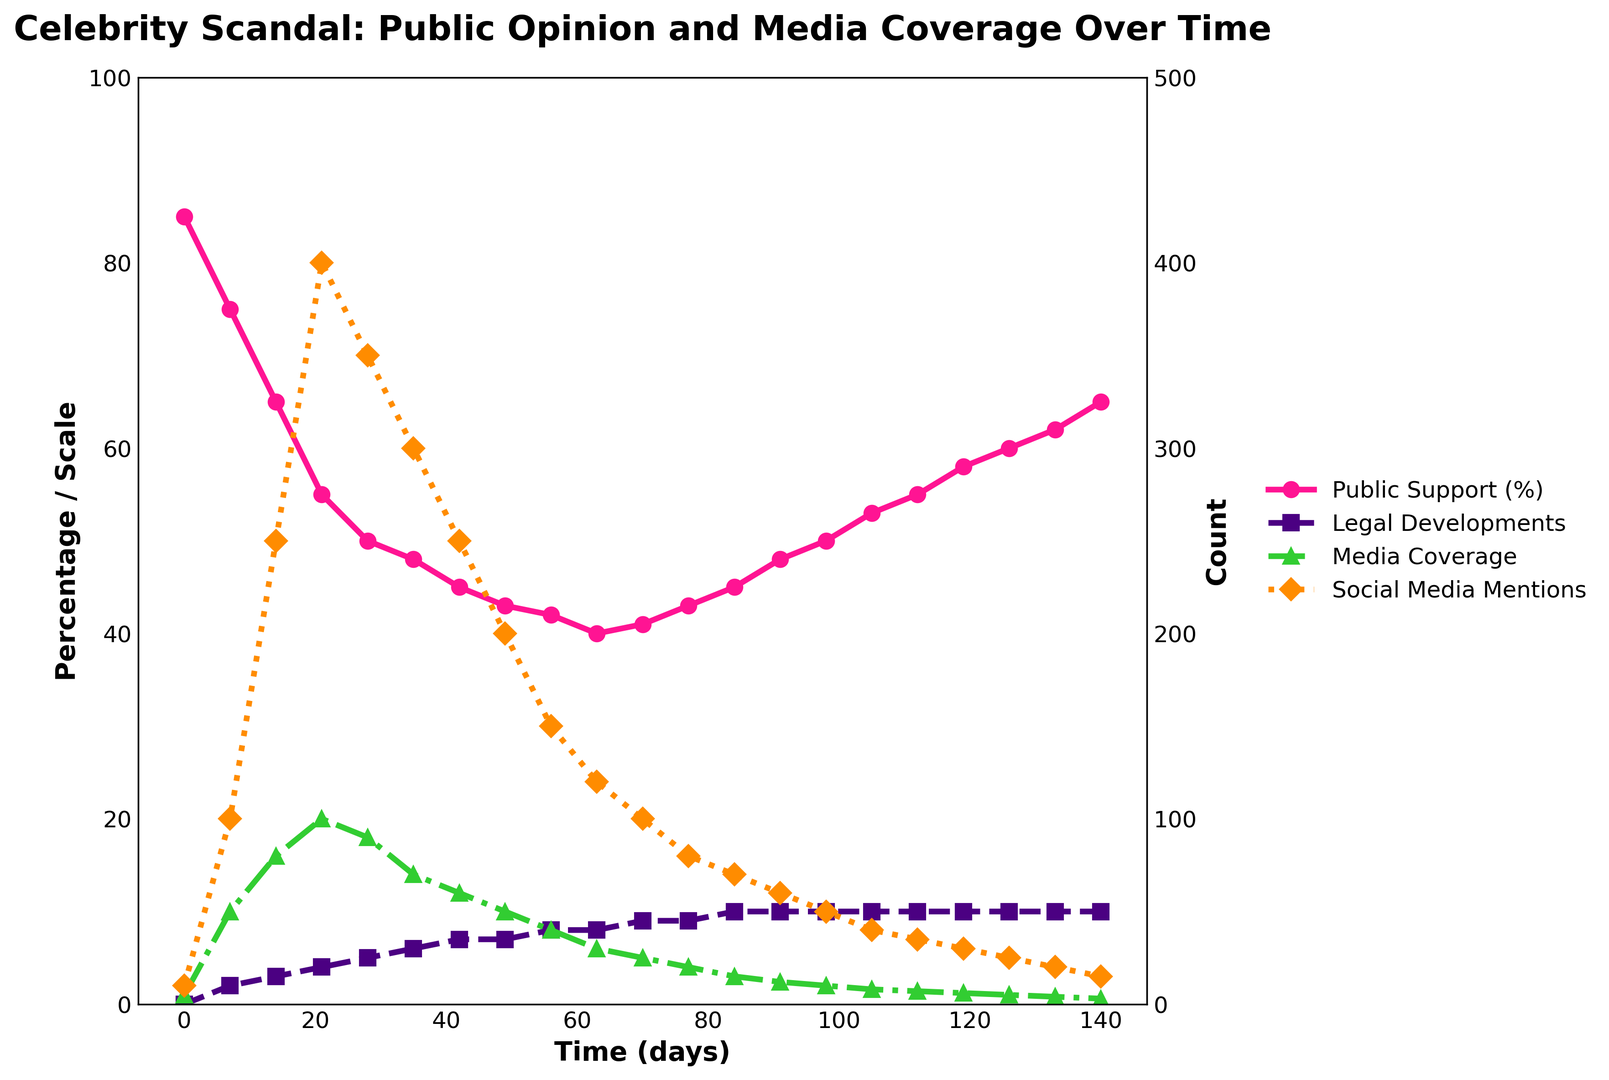What trend can you observe in Public Support (%) over time? Public Support (%) starts high at 85%, then decreases steadily until reaching its lowest point around day 63 at 40%. It then gradually increases again, reaching 65% by day 140.
Answer: Public Support (%) declines initially, then recovers How does Media Coverage change between day 0 and day 21? Media Coverage increases sharply from 5 articles/day on day 0 to 100 articles/day on day 21.
Answer: It increases sharply Compare the peak values of Social Media Mentions and Media Coverage. Which one has a higher peak, and by how much? The peak value of Social Media Mentions is 400 thousand/day (day 21), while Media Coverage peaks at 100 articles/day (day 21). Therefore, Social Media Mentions peak is higher by 400 - 100 = 300
Answer: Social Media Mentions peak is higher by 300 What happens to Legal Developments scale as Public Support (%) starts to recover? When Public Support (%) starts to recover around day 63, Legal Developments scale remains at 10 from day 84 onwards.
Answer: It remains constant at 10 Calculate the average Media Coverage between day 0 and day 14. Media Coverage values are 5, 50, and 80 articles/day between day 0 and day 14. The average is (5 + 50 + 80) / 3 = 135 / 3 = 45 articles/day.
Answer: 45 articles/day Which day shows the highest Social Media Mentions? What is the corresponding Public Support (%) on that day? Social Media Mentions peak at 400 thousand/day on day 21. The corresponding Public Support (%) is 55% on that day.
Answer: Day 21, 55% Are Media Coverage and Social Media Mentions positively or negatively correlated during the scandal? Both Media Coverage and Social Media Mentions increase to their peaks around day 21 and then decrease together over time, indicating a positive correlation.
Answer: Positively correlated Between which days does Public Support (%) show the most significant decline? Public Support (%) shows the most significant decline from 85% on day 0 to 55% on day 21, a drop of 30%.
Answer: Day 0 to day 21 What is the difference in Public Support (%) between its lowest and highest points? The lowest Public Support (%) is 40% on day 63, and the highest is 85% on day 0. The difference is 85 - 40 = 45.
Answer: 45 How does the trend in Legal Developments correspond to the trend in Public Support (%)? As Legal Developments scale increases from 0 to 10, Public Support (%) initially declines until day 63 but then starts to recover despite Legal Developments scale remaining high from day 84 onwards.
Answer: Initially inversely, then stabilizes 